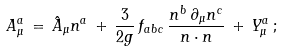<formula> <loc_0><loc_0><loc_500><loc_500>A _ { \mu } ^ { a } \, = \, \hat { A } _ { \mu } n ^ { a } \, + \, \frac { 3 } { 2 g } \, f _ { a b c } \, \frac { n ^ { b } \, \partial _ { \mu } n ^ { c } } { n \cdot n } \, + \, Y _ { \mu } ^ { a } \, ;</formula> 